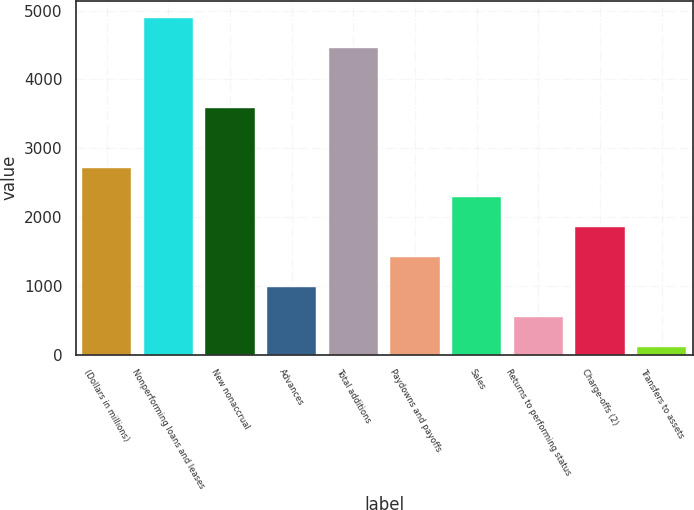Convert chart to OTSL. <chart><loc_0><loc_0><loc_500><loc_500><bar_chart><fcel>(Dollars in millions)<fcel>Nonperforming loans and leases<fcel>New nonaccrual<fcel>Advances<fcel>Total additions<fcel>Paydowns and payoffs<fcel>Sales<fcel>Returns to performing status<fcel>Charge-offs (2)<fcel>Transfers to assets<nl><fcel>2719.8<fcel>4896.3<fcel>3590.4<fcel>978.6<fcel>4461<fcel>1413.9<fcel>2284.5<fcel>543.3<fcel>1849.2<fcel>108<nl></chart> 